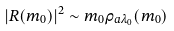Convert formula to latex. <formula><loc_0><loc_0><loc_500><loc_500>| R ( m _ { 0 } ) | ^ { 2 } \sim m _ { 0 } \rho _ { a \lambda _ { 0 } } ( m _ { 0 } )</formula> 